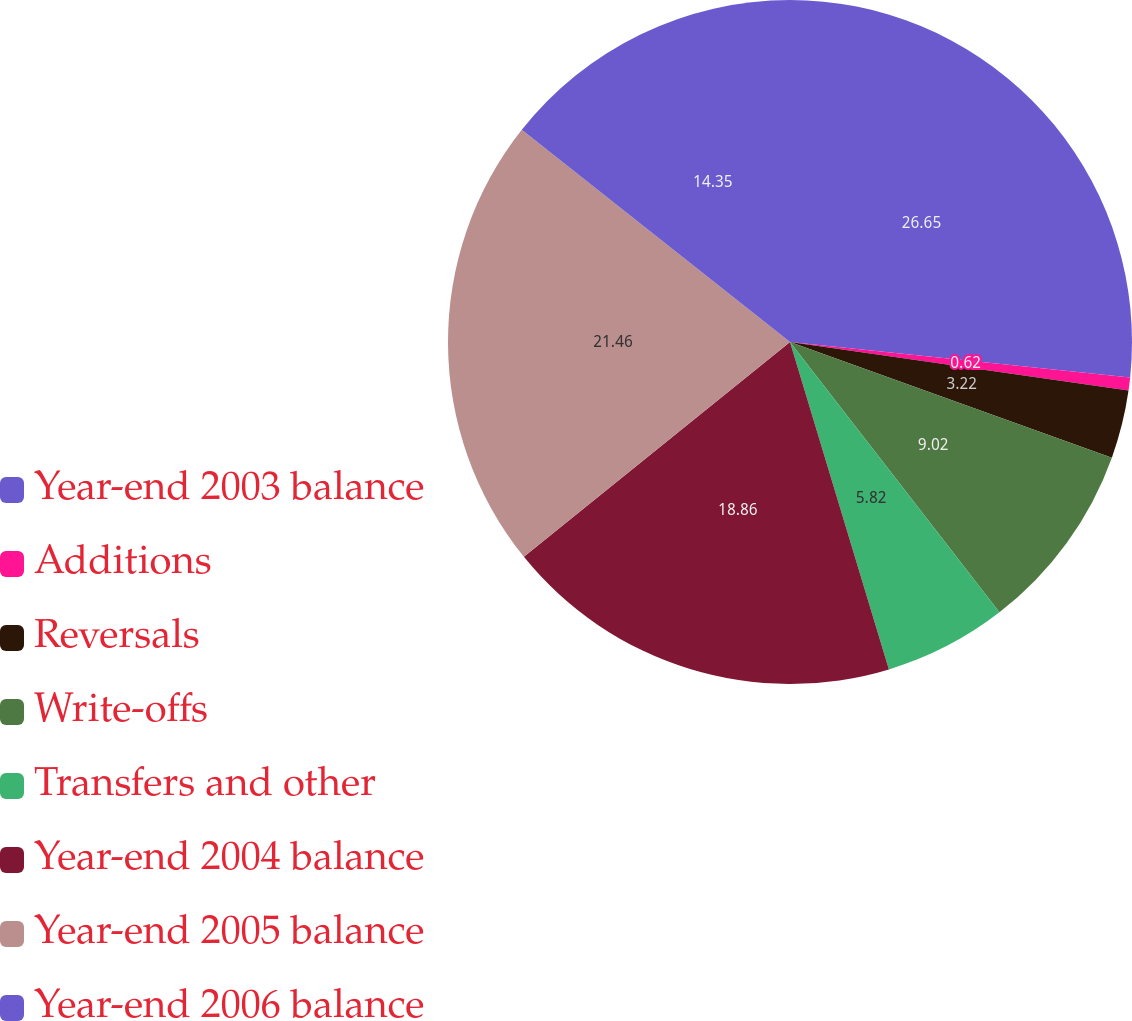<chart> <loc_0><loc_0><loc_500><loc_500><pie_chart><fcel>Year-end 2003 balance<fcel>Additions<fcel>Reversals<fcel>Write-offs<fcel>Transfers and other<fcel>Year-end 2004 balance<fcel>Year-end 2005 balance<fcel>Year-end 2006 balance<nl><fcel>26.65%<fcel>0.62%<fcel>3.22%<fcel>9.02%<fcel>5.82%<fcel>18.86%<fcel>21.46%<fcel>14.35%<nl></chart> 